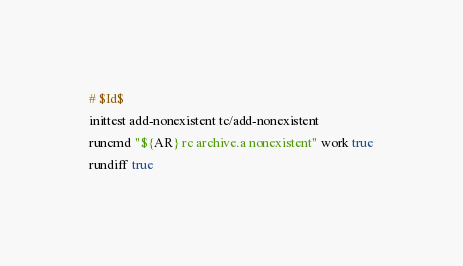<code> <loc_0><loc_0><loc_500><loc_500><_Bash_># $Id$
inittest add-nonexistent tc/add-nonexistent
runcmd "${AR} rc archive.a nonexistent" work true
rundiff true
</code> 